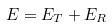Convert formula to latex. <formula><loc_0><loc_0><loc_500><loc_500>E = E _ { T } + E _ { R }</formula> 